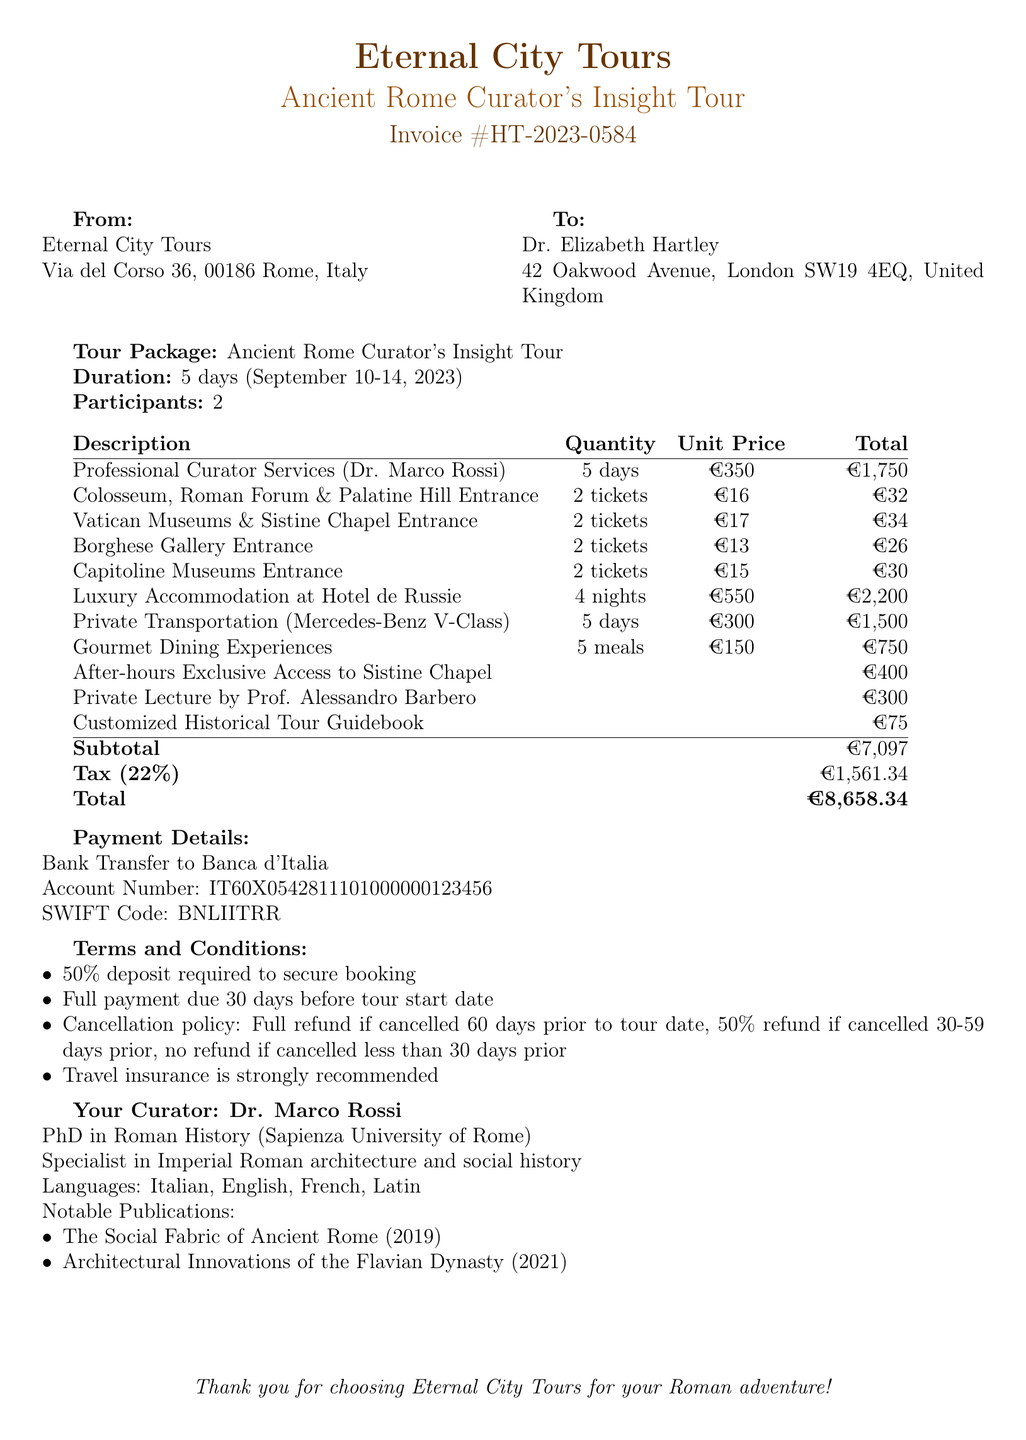what is the invoice number? The invoice number is listed as a unique identifier for this transaction, which is HT-2023-0584.
Answer: HT-2023-0584 who is the customer? The customer name is specified in the document, identifying the individual for whom the invoice is issued, which is Dr. Elizabeth Hartley.
Answer: Dr. Elizabeth Hartley what is the total amount due? The total amount due is prominently displayed in the payment details section, which is €8,658.34.
Answer: €8,658.34 how many participants are on the tour? The document indicates the number of participants in the tour package, which is 2.
Answer: 2 what is the price for professional curator services? The price for professional curator services is calculated based on the quantity and unit price detailed in the itemized costs, which totals €1,750.
Answer: €1,750 when is the payment due date? The due date for the payment is specified in the invoice details, which is June 15, 2023.
Answer: June 15, 2023 how many nights is the accommodation provided? The duration of the accommodation included in the tour package is detailed in the itemized costs, which shows 4 nights.
Answer: 4 nights what is the cancellation policy for the tour? The cancellation policy outlines the refund conditions based on the timing of the cancellation, which includes various percentages depending on the notice given prior to the tour date.
Answer: Full refund if cancelled 60 days prior to tour date what additional service costs €400? The document lists various additional services, one of which is the After-hours Exclusive Access to Sistine Chapel, priced at €400.
Answer: After-hours Exclusive Access to Sistine Chapel 